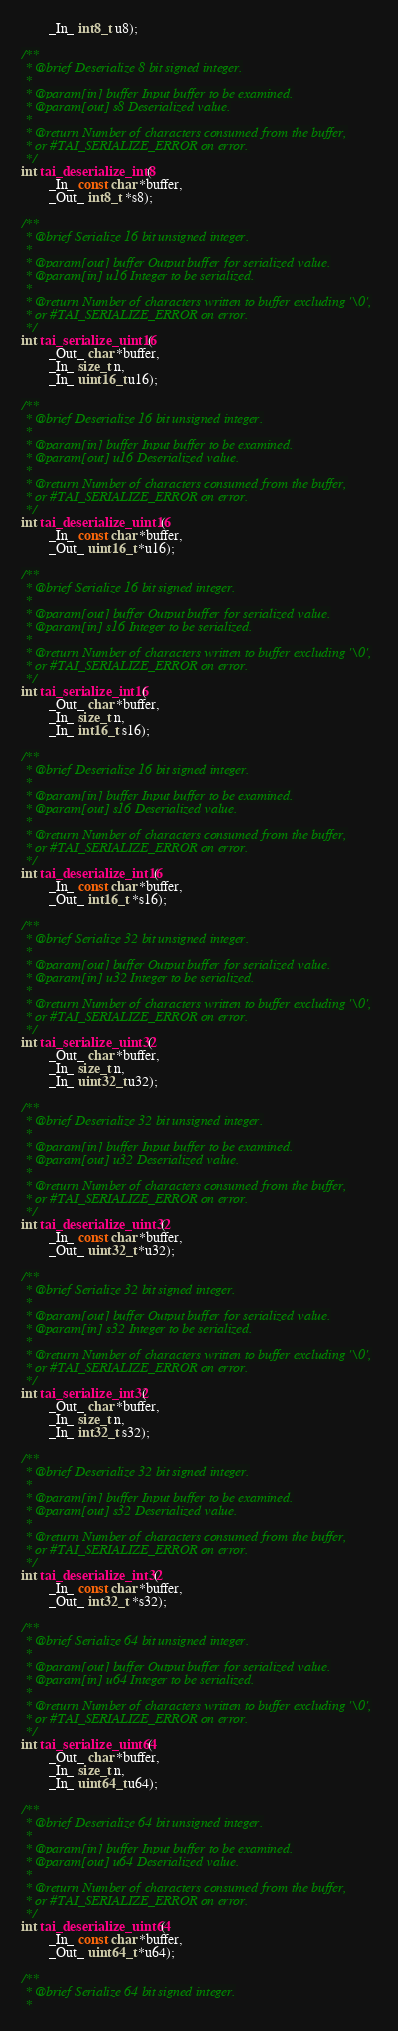Convert code to text. <code><loc_0><loc_0><loc_500><loc_500><_C_>        _In_ int8_t u8);

/**
 * @brief Deserialize 8 bit signed integer.
 *
 * @param[in] buffer Input buffer to be examined.
 * @param[out] s8 Deserialized value.
 *
 * @return Number of characters consumed from the buffer,
 * or #TAI_SERIALIZE_ERROR on error.
 */
int tai_deserialize_int8(
        _In_ const char *buffer,
        _Out_ int8_t *s8);

/**
 * @brief Serialize 16 bit unsigned integer.
 *
 * @param[out] buffer Output buffer for serialized value.
 * @param[in] u16 Integer to be serialized.
 *
 * @return Number of characters written to buffer excluding '\0',
 * or #TAI_SERIALIZE_ERROR on error.
 */
int tai_serialize_uint16(
        _Out_ char *buffer,
        _In_ size_t n,
        _In_ uint16_t u16);

/**
 * @brief Deserialize 16 bit unsigned integer.
 *
 * @param[in] buffer Input buffer to be examined.
 * @param[out] u16 Deserialized value.
 *
 * @return Number of characters consumed from the buffer,
 * or #TAI_SERIALIZE_ERROR on error.
 */
int tai_deserialize_uint16(
        _In_ const char *buffer,
        _Out_ uint16_t *u16);

/**
 * @brief Serialize 16 bit signed integer.
 *
 * @param[out] buffer Output buffer for serialized value.
 * @param[in] s16 Integer to be serialized.
 *
 * @return Number of characters written to buffer excluding '\0',
 * or #TAI_SERIALIZE_ERROR on error.
 */
int tai_serialize_int16(
        _Out_ char *buffer,
        _In_ size_t n,
        _In_ int16_t s16);

/**
 * @brief Deserialize 16 bit signed integer.
 *
 * @param[in] buffer Input buffer to be examined.
 * @param[out] s16 Deserialized value.
 *
 * @return Number of characters consumed from the buffer,
 * or #TAI_SERIALIZE_ERROR on error.
 */
int tai_deserialize_int16(
        _In_ const char *buffer,
        _Out_ int16_t *s16);

/**
 * @brief Serialize 32 bit unsigned integer.
 *
 * @param[out] buffer Output buffer for serialized value.
 * @param[in] u32 Integer to be serialized.
 *
 * @return Number of characters written to buffer excluding '\0',
 * or #TAI_SERIALIZE_ERROR on error.
 */
int tai_serialize_uint32(
        _Out_ char *buffer,
        _In_ size_t n,
        _In_ uint32_t u32);

/**
 * @brief Deserialize 32 bit unsigned integer.
 *
 * @param[in] buffer Input buffer to be examined.
 * @param[out] u32 Deserialized value.
 *
 * @return Number of characters consumed from the buffer,
 * or #TAI_SERIALIZE_ERROR on error.
 */
int tai_deserialize_uint32(
        _In_ const char *buffer,
        _Out_ uint32_t *u32);

/**
 * @brief Serialize 32 bit signed integer.
 *
 * @param[out] buffer Output buffer for serialized value.
 * @param[in] s32 Integer to be serialized.
 *
 * @return Number of characters written to buffer excluding '\0',
 * or #TAI_SERIALIZE_ERROR on error.
 */
int tai_serialize_int32(
        _Out_ char *buffer,
        _In_ size_t n,
        _In_ int32_t s32);

/**
 * @brief Deserialize 32 bit signed integer.
 *
 * @param[in] buffer Input buffer to be examined.
 * @param[out] s32 Deserialized value.
 *
 * @return Number of characters consumed from the buffer,
 * or #TAI_SERIALIZE_ERROR on error.
 */
int tai_deserialize_int32(
        _In_ const char *buffer,
        _Out_ int32_t *s32);

/**
 * @brief Serialize 64 bit unsigned integer.
 *
 * @param[out] buffer Output buffer for serialized value.
 * @param[in] u64 Integer to be serialized.
 *
 * @return Number of characters written to buffer excluding '\0',
 * or #TAI_SERIALIZE_ERROR on error.
 */
int tai_serialize_uint64(
        _Out_ char *buffer,
        _In_ size_t n,
        _In_ uint64_t u64);

/**
 * @brief Deserialize 64 bit unsigned integer.
 *
 * @param[in] buffer Input buffer to be examined.
 * @param[out] u64 Deserialized value.
 *
 * @return Number of characters consumed from the buffer,
 * or #TAI_SERIALIZE_ERROR on error.
 */
int tai_deserialize_uint64(
        _In_ const char *buffer,
        _Out_ uint64_t *u64);

/**
 * @brief Serialize 64 bit signed integer.
 *</code> 